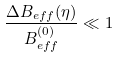Convert formula to latex. <formula><loc_0><loc_0><loc_500><loc_500>\frac { \Delta B _ { e f f } ( \eta ) } { B _ { e f f } ^ { ( 0 ) } } \ll 1</formula> 